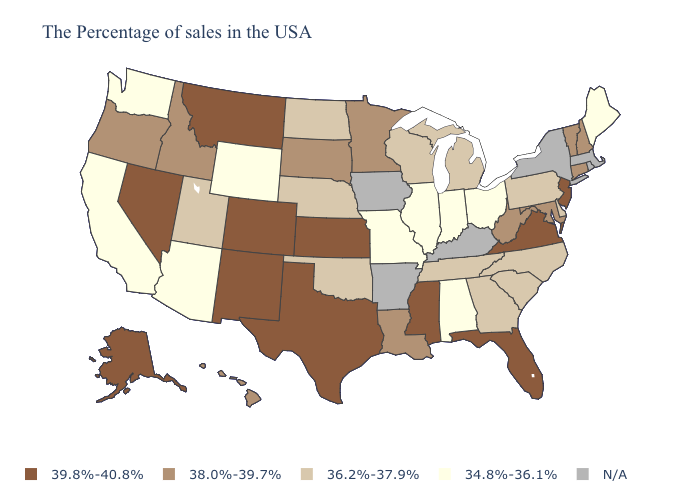Does the map have missing data?
Give a very brief answer. Yes. Name the states that have a value in the range 34.8%-36.1%?
Keep it brief. Maine, Ohio, Indiana, Alabama, Illinois, Missouri, Wyoming, Arizona, California, Washington. Name the states that have a value in the range 38.0%-39.7%?
Be succinct. New Hampshire, Vermont, Connecticut, Maryland, West Virginia, Louisiana, Minnesota, South Dakota, Idaho, Oregon, Hawaii. What is the value of Michigan?
Give a very brief answer. 36.2%-37.9%. Which states have the highest value in the USA?
Answer briefly. New Jersey, Virginia, Florida, Mississippi, Kansas, Texas, Colorado, New Mexico, Montana, Nevada, Alaska. What is the value of Nevada?
Answer briefly. 39.8%-40.8%. What is the value of Kansas?
Answer briefly. 39.8%-40.8%. What is the value of New Hampshire?
Concise answer only. 38.0%-39.7%. Does Kansas have the lowest value in the USA?
Be succinct. No. Name the states that have a value in the range 39.8%-40.8%?
Give a very brief answer. New Jersey, Virginia, Florida, Mississippi, Kansas, Texas, Colorado, New Mexico, Montana, Nevada, Alaska. Among the states that border Nevada , does Utah have the lowest value?
Keep it brief. No. Name the states that have a value in the range 36.2%-37.9%?
Give a very brief answer. Delaware, Pennsylvania, North Carolina, South Carolina, Georgia, Michigan, Tennessee, Wisconsin, Nebraska, Oklahoma, North Dakota, Utah. What is the highest value in the South ?
Concise answer only. 39.8%-40.8%. 